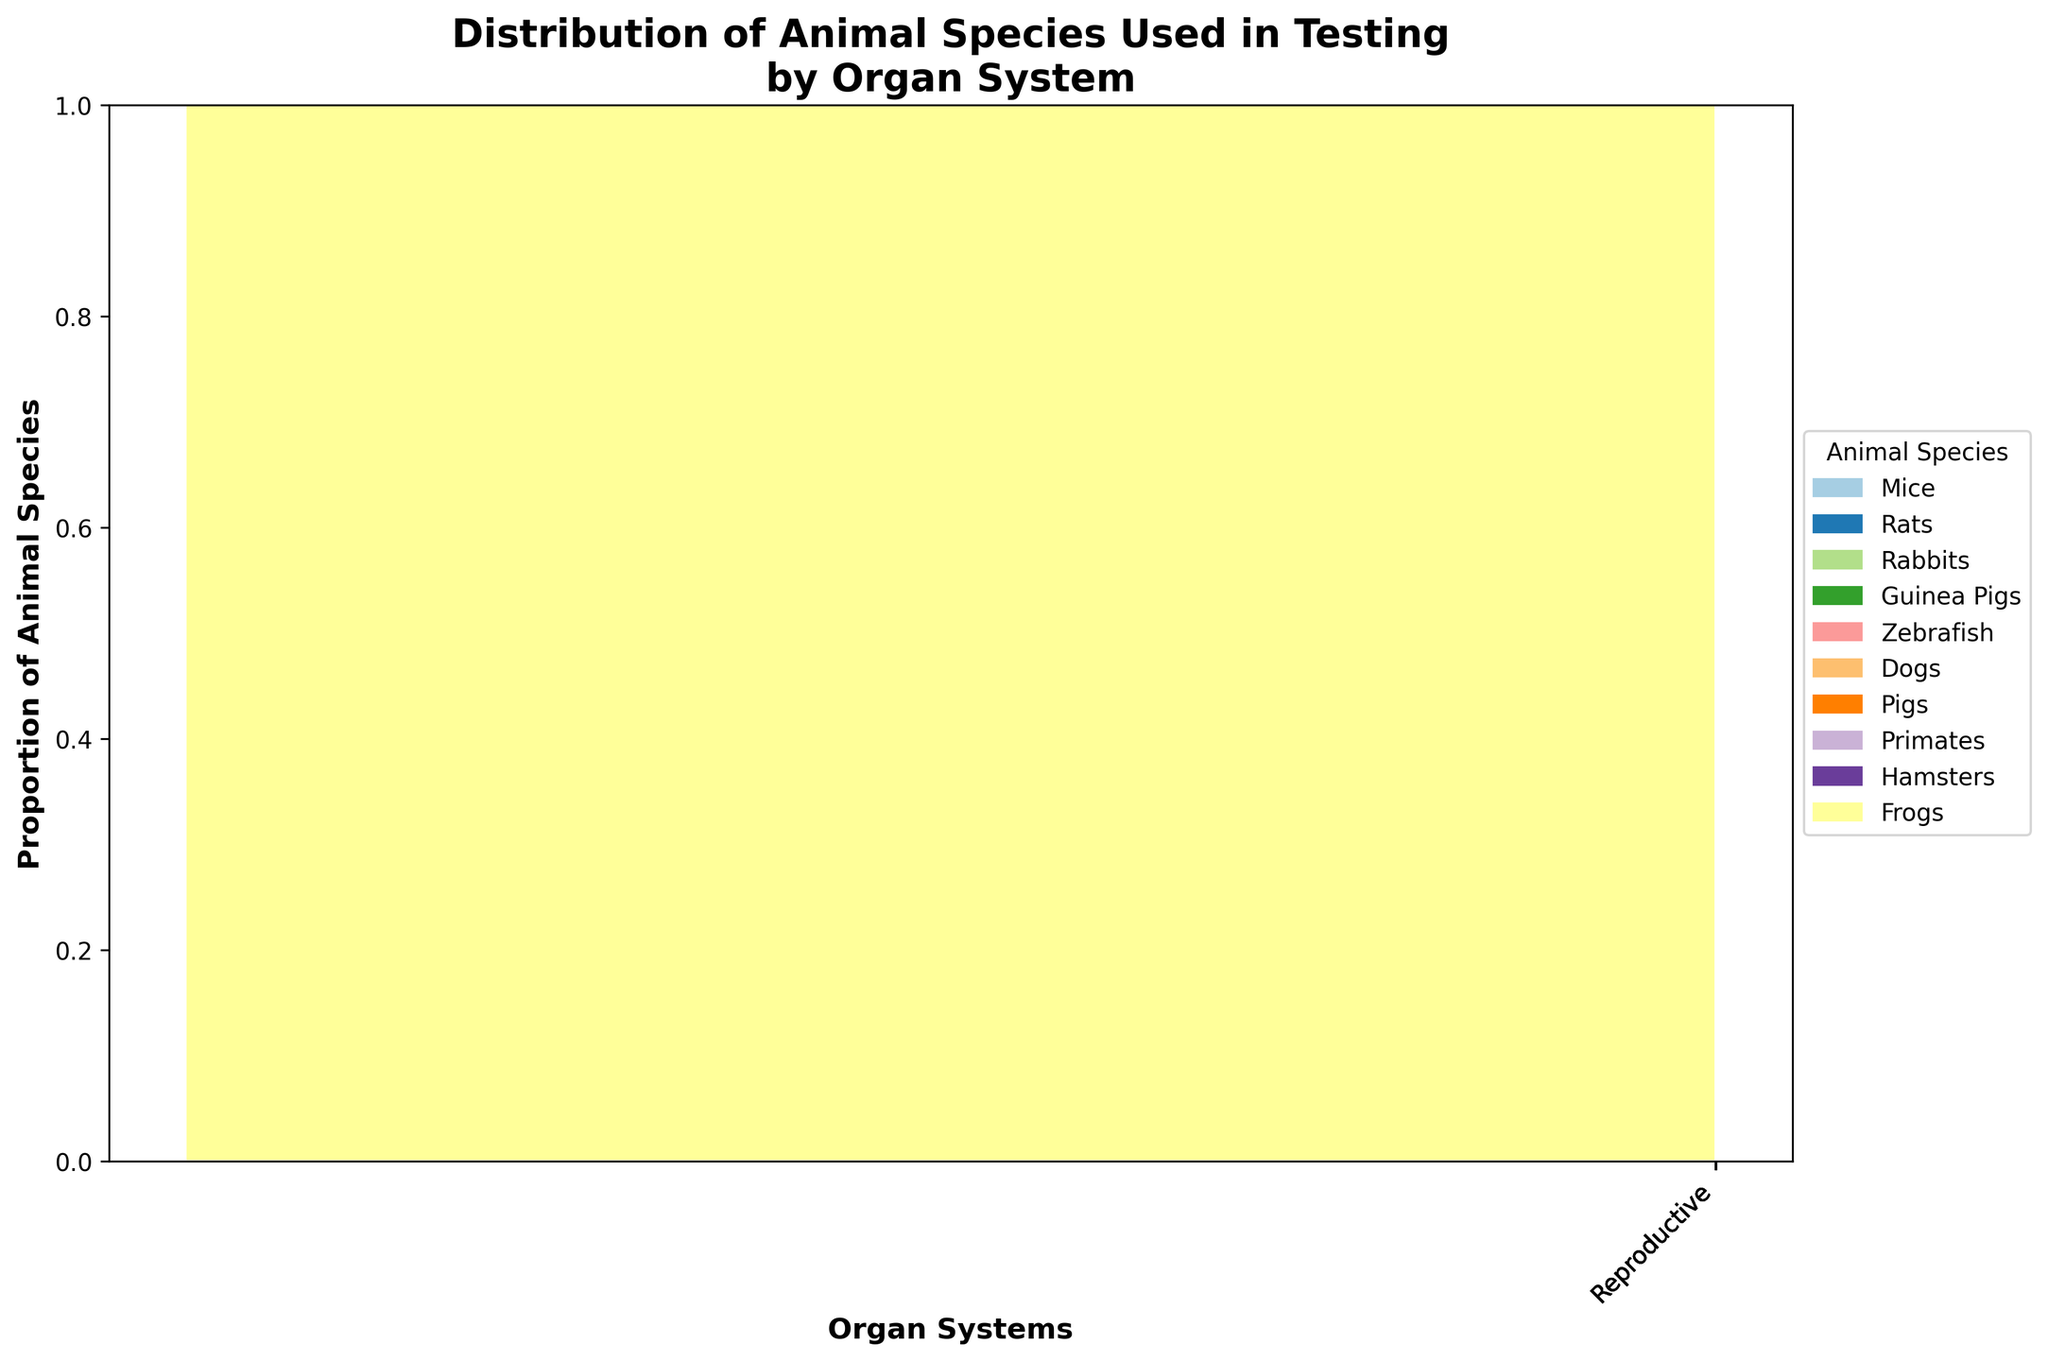What is the title of the figure? The title is usually located at the top of the plot. In this figure, it reads "Distribution of Animal Species Used in Testing by Organ System".
Answer: Distribution of Animal Species Used in Testing by Organ System What does the x-axis represent? The x-axis labels indicate the categories of the organ systems involved in the testing. These labels are present at the bottom of the figure along the horizontal axis.
Answer: Organ Systems Which animal species is associated with the Cardiovascular system? To find the specific association, look at the portion of the Mosaic plot allocated to the Cardiovascular system and identify the corresponding animal species from the legend.
Answer: Mice What is the synthetic tissue replacement for the Nervous system? The annotations above the corresponding sections of the plot indicate the synthetic tissue replacements. The one for the Nervous system can be found above its section.
Answer: Brain Organoids How many different organ systems are represented in the plot? Counting the unique labels on the x-axis provides the number of different organ systems. There are ten individually labeled categories.
Answer: 10 Which animal species is least represented in the plot? Evaluate the sizes of the bars associated with each animal species. The species linked to the smallest proportional area in any of the organ system categories is the least represented.
Answer: Frogs What is the relationship between the Musculoskeletal system and its synthetic tissue replacement? Refer to the annotation directly above the Musculoskeletal section of the plot. This shows the associated synthetic tissue replacement.
Answer: 3D Bioprinted Bone Which organ system is associated with 3D Printed Skin Models? Check the annotations provided above the sections of the plot for each organ system to find where 3D Printed Skin Models are listed.
Answer: Integumentary Compare the proportion of Dogs and Rats used. Which one is more prevalent? Compare the heights of the bars representing Dogs and Rats across their respective organ systems. The taller bar indicates the more prevalent species.
Answer: Dogs How many synthetic tissue replacements are intended for animals tested for the Immune system? Look for the section of the plot associated with the Immune system and refer to the annotation for the number of synthetic tissue replacements intended for animals in this category.
Answer: Lymph Node Organoids 